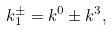Convert formula to latex. <formula><loc_0><loc_0><loc_500><loc_500>k _ { 1 } ^ { \pm } = k ^ { 0 } \pm k ^ { 3 } ,</formula> 